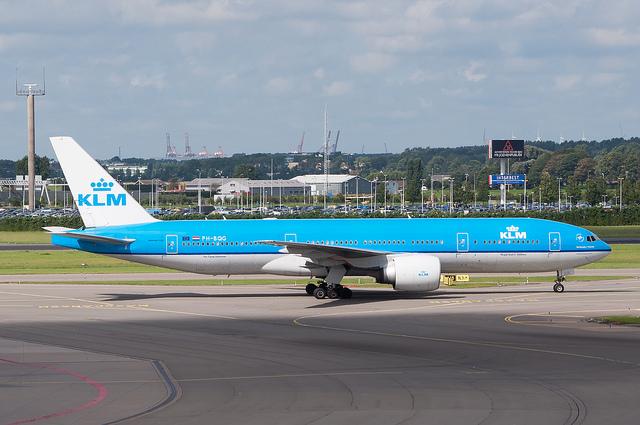Is this a Dutch airliner?
Keep it brief. Yes. What is the color of the plane?
Concise answer only. Blue. What color is the plane?
Give a very brief answer. Blue and white. What are the letters on this airplane?
Quick response, please. Klm. What is the text on the tail of the airplane?
Concise answer only. Klm. 